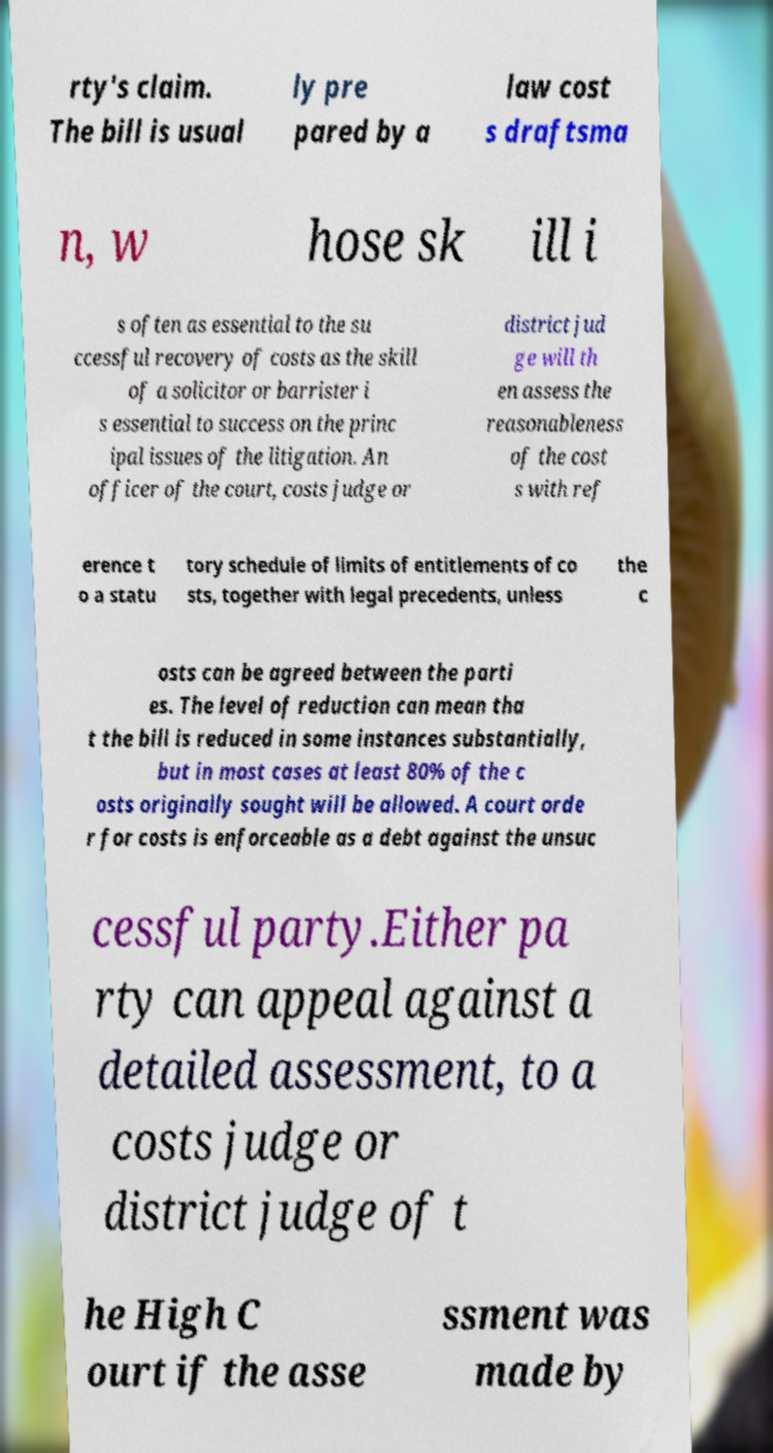There's text embedded in this image that I need extracted. Can you transcribe it verbatim? rty's claim. The bill is usual ly pre pared by a law cost s draftsma n, w hose sk ill i s often as essential to the su ccessful recovery of costs as the skill of a solicitor or barrister i s essential to success on the princ ipal issues of the litigation. An officer of the court, costs judge or district jud ge will th en assess the reasonableness of the cost s with ref erence t o a statu tory schedule of limits of entitlements of co sts, together with legal precedents, unless the c osts can be agreed between the parti es. The level of reduction can mean tha t the bill is reduced in some instances substantially, but in most cases at least 80% of the c osts originally sought will be allowed. A court orde r for costs is enforceable as a debt against the unsuc cessful party.Either pa rty can appeal against a detailed assessment, to a costs judge or district judge of t he High C ourt if the asse ssment was made by 